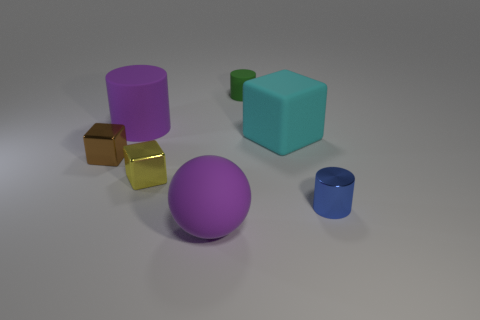Subtract all tiny shiny blocks. How many blocks are left? 1 Add 2 big cyan rubber objects. How many objects exist? 9 Subtract all spheres. How many objects are left? 6 Add 3 large purple things. How many large purple things are left? 5 Add 2 cyan matte things. How many cyan matte things exist? 3 Subtract 1 brown cubes. How many objects are left? 6 Subtract all small metal things. Subtract all purple metal cylinders. How many objects are left? 4 